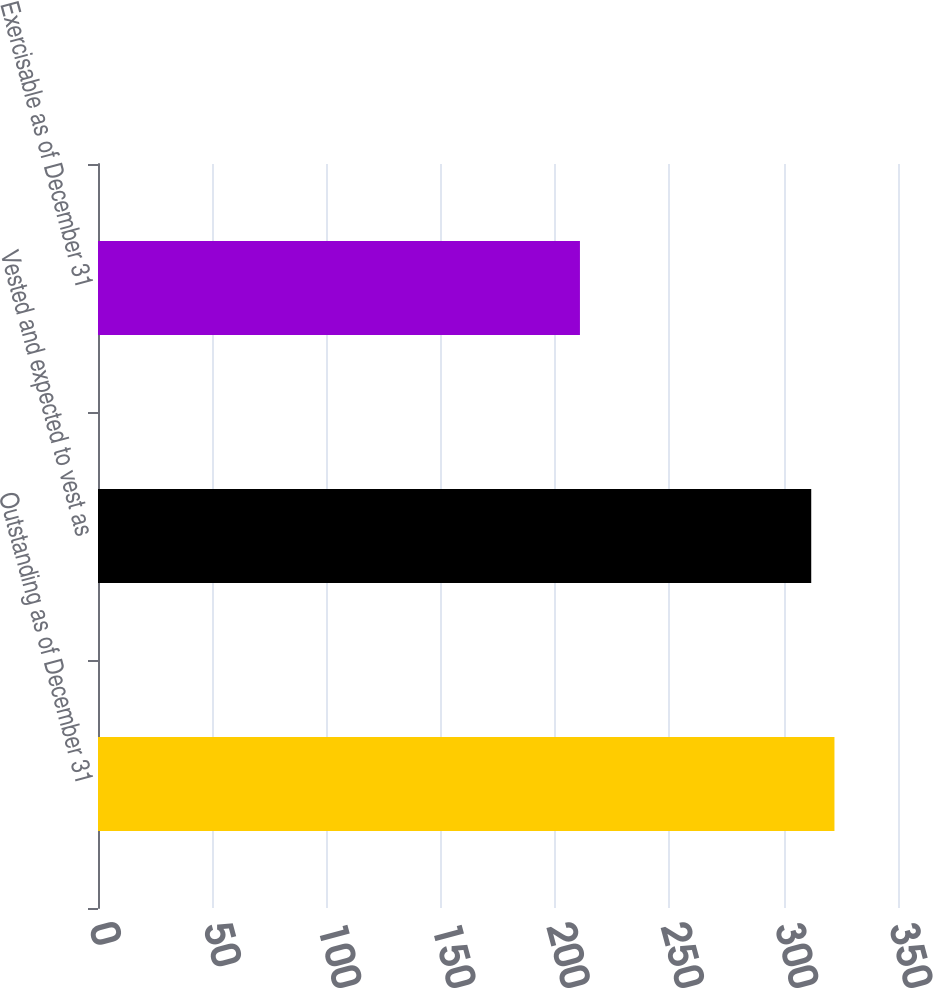<chart> <loc_0><loc_0><loc_500><loc_500><bar_chart><fcel>Outstanding as of December 31<fcel>Vested and expected to vest as<fcel>Exercisable as of December 31<nl><fcel>322.2<fcel>312.04<fcel>210.85<nl></chart> 